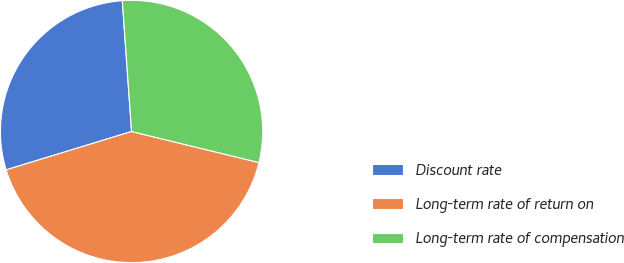Convert chart. <chart><loc_0><loc_0><loc_500><loc_500><pie_chart><fcel>Discount rate<fcel>Long-term rate of return on<fcel>Long-term rate of compensation<nl><fcel>28.6%<fcel>41.47%<fcel>29.93%<nl></chart> 